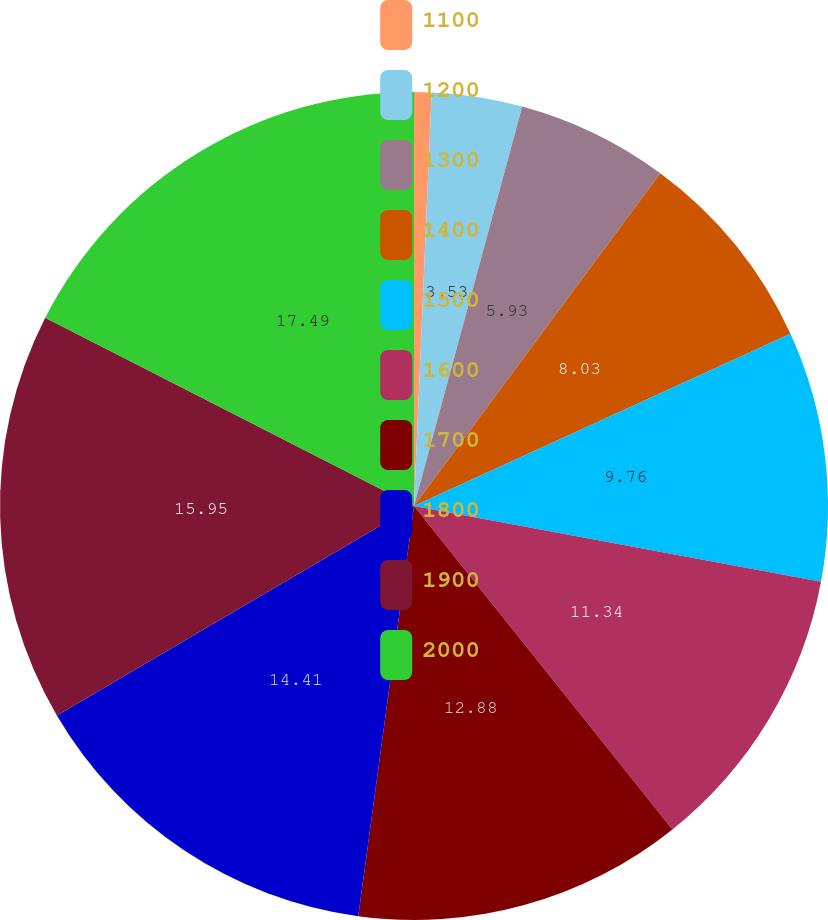Convert chart to OTSL. <chart><loc_0><loc_0><loc_500><loc_500><pie_chart><fcel>1100<fcel>1200<fcel>1300<fcel>1400<fcel>1500<fcel>1600<fcel>1700<fcel>1800<fcel>1900<fcel>2000<nl><fcel>0.68%<fcel>3.53%<fcel>5.93%<fcel>8.03%<fcel>9.76%<fcel>11.34%<fcel>12.88%<fcel>14.41%<fcel>15.95%<fcel>17.49%<nl></chart> 